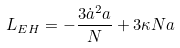<formula> <loc_0><loc_0><loc_500><loc_500>L _ { E H } = - \frac { 3 \dot { a } ^ { 2 } a } { N } + 3 \kappa N a</formula> 